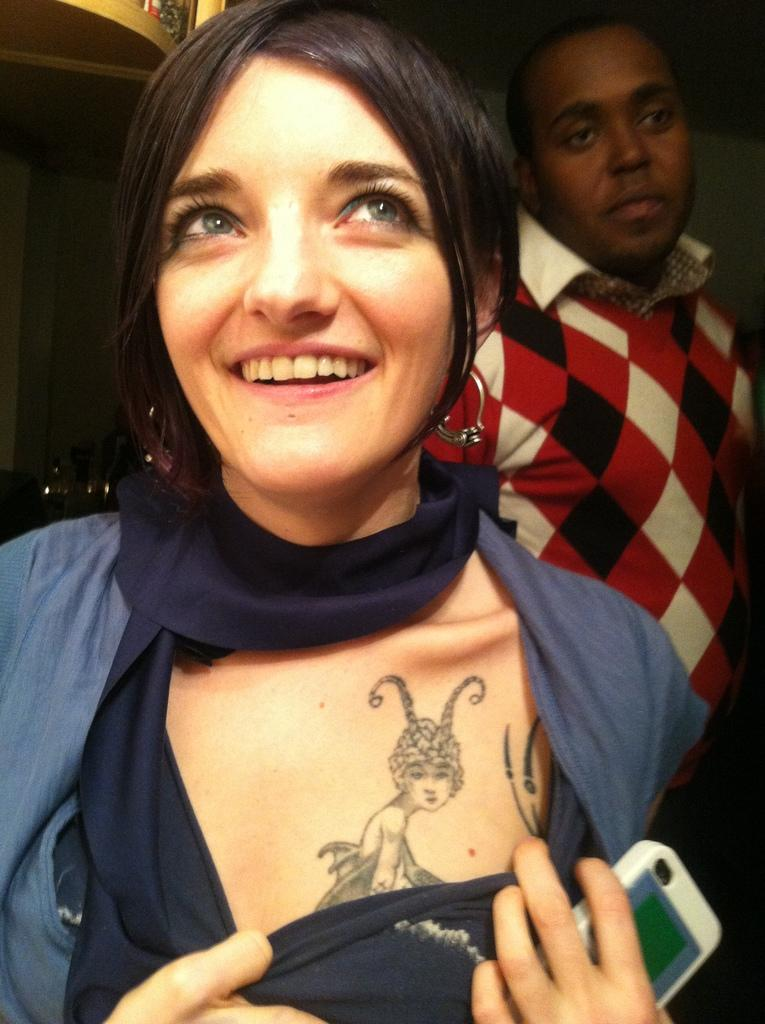Who is present in the image? There is a woman and a man in the image. What is the woman doing in the image? The woman is smiling and holding a mobile. How is the man positioned in relation to the woman? The man is standing behind the woman. What type of rod can be seen in the woman's nose in the image? There is no rod or any object in the woman's nose in the image. 